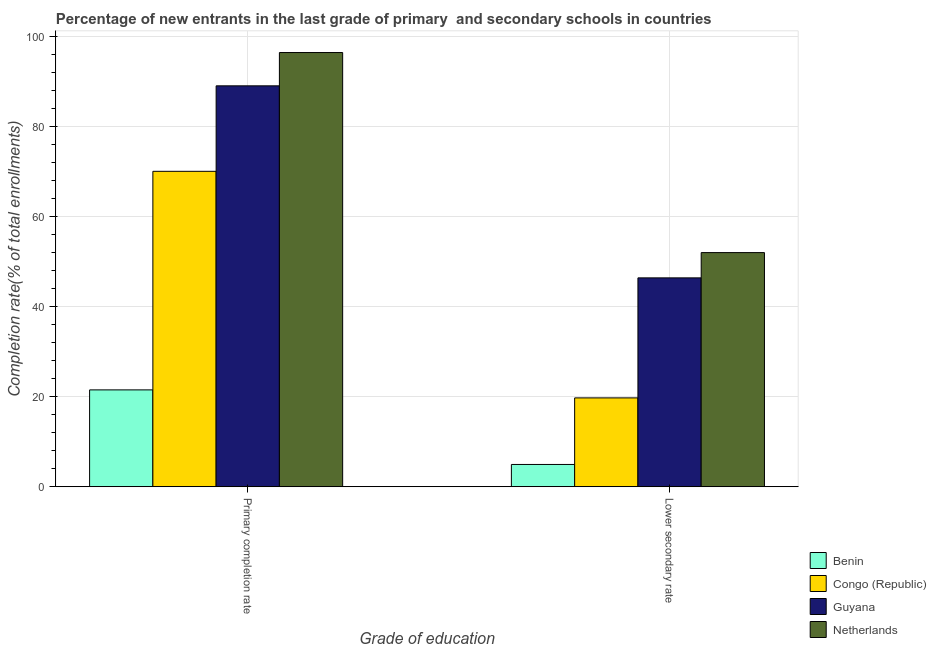How many groups of bars are there?
Give a very brief answer. 2. Are the number of bars on each tick of the X-axis equal?
Give a very brief answer. Yes. How many bars are there on the 1st tick from the right?
Provide a short and direct response. 4. What is the label of the 2nd group of bars from the left?
Offer a terse response. Lower secondary rate. What is the completion rate in secondary schools in Guyana?
Your answer should be very brief. 46.39. Across all countries, what is the maximum completion rate in primary schools?
Your response must be concise. 96.44. Across all countries, what is the minimum completion rate in primary schools?
Give a very brief answer. 21.51. In which country was the completion rate in secondary schools minimum?
Provide a short and direct response. Benin. What is the total completion rate in primary schools in the graph?
Make the answer very short. 277.05. What is the difference between the completion rate in primary schools in Guyana and that in Netherlands?
Your answer should be compact. -7.4. What is the difference between the completion rate in secondary schools in Netherlands and the completion rate in primary schools in Congo (Republic)?
Your response must be concise. -18.05. What is the average completion rate in primary schools per country?
Keep it short and to the point. 69.26. What is the difference between the completion rate in secondary schools and completion rate in primary schools in Netherlands?
Ensure brevity in your answer.  -44.44. In how many countries, is the completion rate in primary schools greater than 60 %?
Your response must be concise. 3. What is the ratio of the completion rate in secondary schools in Guyana to that in Congo (Republic)?
Your answer should be compact. 2.35. Is the completion rate in secondary schools in Benin less than that in Congo (Republic)?
Your response must be concise. Yes. What does the 4th bar from the left in Primary completion rate represents?
Ensure brevity in your answer.  Netherlands. What does the 3rd bar from the right in Primary completion rate represents?
Give a very brief answer. Congo (Republic). How many bars are there?
Offer a very short reply. 8. Are all the bars in the graph horizontal?
Make the answer very short. No. Are the values on the major ticks of Y-axis written in scientific E-notation?
Offer a terse response. No. Does the graph contain any zero values?
Your response must be concise. No. Where does the legend appear in the graph?
Provide a short and direct response. Bottom right. What is the title of the graph?
Give a very brief answer. Percentage of new entrants in the last grade of primary  and secondary schools in countries. What is the label or title of the X-axis?
Your answer should be compact. Grade of education. What is the label or title of the Y-axis?
Ensure brevity in your answer.  Completion rate(% of total enrollments). What is the Completion rate(% of total enrollments) in Benin in Primary completion rate?
Keep it short and to the point. 21.51. What is the Completion rate(% of total enrollments) in Congo (Republic) in Primary completion rate?
Your response must be concise. 70.06. What is the Completion rate(% of total enrollments) of Guyana in Primary completion rate?
Provide a short and direct response. 89.05. What is the Completion rate(% of total enrollments) in Netherlands in Primary completion rate?
Provide a succinct answer. 96.44. What is the Completion rate(% of total enrollments) in Benin in Lower secondary rate?
Offer a very short reply. 4.94. What is the Completion rate(% of total enrollments) in Congo (Republic) in Lower secondary rate?
Make the answer very short. 19.73. What is the Completion rate(% of total enrollments) in Guyana in Lower secondary rate?
Give a very brief answer. 46.39. What is the Completion rate(% of total enrollments) of Netherlands in Lower secondary rate?
Offer a very short reply. 52. Across all Grade of education, what is the maximum Completion rate(% of total enrollments) of Benin?
Your answer should be compact. 21.51. Across all Grade of education, what is the maximum Completion rate(% of total enrollments) in Congo (Republic)?
Your answer should be very brief. 70.06. Across all Grade of education, what is the maximum Completion rate(% of total enrollments) of Guyana?
Your answer should be very brief. 89.05. Across all Grade of education, what is the maximum Completion rate(% of total enrollments) in Netherlands?
Ensure brevity in your answer.  96.44. Across all Grade of education, what is the minimum Completion rate(% of total enrollments) in Benin?
Your response must be concise. 4.94. Across all Grade of education, what is the minimum Completion rate(% of total enrollments) of Congo (Republic)?
Your answer should be compact. 19.73. Across all Grade of education, what is the minimum Completion rate(% of total enrollments) of Guyana?
Your response must be concise. 46.39. Across all Grade of education, what is the minimum Completion rate(% of total enrollments) in Netherlands?
Your response must be concise. 52. What is the total Completion rate(% of total enrollments) in Benin in the graph?
Your response must be concise. 26.45. What is the total Completion rate(% of total enrollments) in Congo (Republic) in the graph?
Ensure brevity in your answer.  89.79. What is the total Completion rate(% of total enrollments) in Guyana in the graph?
Offer a very short reply. 135.44. What is the total Completion rate(% of total enrollments) of Netherlands in the graph?
Keep it short and to the point. 148.45. What is the difference between the Completion rate(% of total enrollments) of Benin in Primary completion rate and that in Lower secondary rate?
Make the answer very short. 16.57. What is the difference between the Completion rate(% of total enrollments) of Congo (Republic) in Primary completion rate and that in Lower secondary rate?
Provide a succinct answer. 50.33. What is the difference between the Completion rate(% of total enrollments) of Guyana in Primary completion rate and that in Lower secondary rate?
Your response must be concise. 42.66. What is the difference between the Completion rate(% of total enrollments) of Netherlands in Primary completion rate and that in Lower secondary rate?
Provide a short and direct response. 44.44. What is the difference between the Completion rate(% of total enrollments) of Benin in Primary completion rate and the Completion rate(% of total enrollments) of Congo (Republic) in Lower secondary rate?
Your answer should be compact. 1.78. What is the difference between the Completion rate(% of total enrollments) of Benin in Primary completion rate and the Completion rate(% of total enrollments) of Guyana in Lower secondary rate?
Offer a very short reply. -24.88. What is the difference between the Completion rate(% of total enrollments) in Benin in Primary completion rate and the Completion rate(% of total enrollments) in Netherlands in Lower secondary rate?
Provide a short and direct response. -30.49. What is the difference between the Completion rate(% of total enrollments) in Congo (Republic) in Primary completion rate and the Completion rate(% of total enrollments) in Guyana in Lower secondary rate?
Give a very brief answer. 23.67. What is the difference between the Completion rate(% of total enrollments) of Congo (Republic) in Primary completion rate and the Completion rate(% of total enrollments) of Netherlands in Lower secondary rate?
Offer a terse response. 18.05. What is the difference between the Completion rate(% of total enrollments) in Guyana in Primary completion rate and the Completion rate(% of total enrollments) in Netherlands in Lower secondary rate?
Keep it short and to the point. 37.04. What is the average Completion rate(% of total enrollments) in Benin per Grade of education?
Offer a very short reply. 13.23. What is the average Completion rate(% of total enrollments) in Congo (Republic) per Grade of education?
Ensure brevity in your answer.  44.89. What is the average Completion rate(% of total enrollments) in Guyana per Grade of education?
Give a very brief answer. 67.72. What is the average Completion rate(% of total enrollments) in Netherlands per Grade of education?
Provide a succinct answer. 74.22. What is the difference between the Completion rate(% of total enrollments) of Benin and Completion rate(% of total enrollments) of Congo (Republic) in Primary completion rate?
Offer a terse response. -48.55. What is the difference between the Completion rate(% of total enrollments) of Benin and Completion rate(% of total enrollments) of Guyana in Primary completion rate?
Make the answer very short. -67.53. What is the difference between the Completion rate(% of total enrollments) in Benin and Completion rate(% of total enrollments) in Netherlands in Primary completion rate?
Offer a very short reply. -74.93. What is the difference between the Completion rate(% of total enrollments) in Congo (Republic) and Completion rate(% of total enrollments) in Guyana in Primary completion rate?
Your answer should be compact. -18.99. What is the difference between the Completion rate(% of total enrollments) in Congo (Republic) and Completion rate(% of total enrollments) in Netherlands in Primary completion rate?
Offer a very short reply. -26.38. What is the difference between the Completion rate(% of total enrollments) in Guyana and Completion rate(% of total enrollments) in Netherlands in Primary completion rate?
Provide a short and direct response. -7.4. What is the difference between the Completion rate(% of total enrollments) of Benin and Completion rate(% of total enrollments) of Congo (Republic) in Lower secondary rate?
Keep it short and to the point. -14.79. What is the difference between the Completion rate(% of total enrollments) of Benin and Completion rate(% of total enrollments) of Guyana in Lower secondary rate?
Provide a short and direct response. -41.45. What is the difference between the Completion rate(% of total enrollments) in Benin and Completion rate(% of total enrollments) in Netherlands in Lower secondary rate?
Give a very brief answer. -47.06. What is the difference between the Completion rate(% of total enrollments) in Congo (Republic) and Completion rate(% of total enrollments) in Guyana in Lower secondary rate?
Make the answer very short. -26.66. What is the difference between the Completion rate(% of total enrollments) of Congo (Republic) and Completion rate(% of total enrollments) of Netherlands in Lower secondary rate?
Provide a short and direct response. -32.27. What is the difference between the Completion rate(% of total enrollments) in Guyana and Completion rate(% of total enrollments) in Netherlands in Lower secondary rate?
Make the answer very short. -5.61. What is the ratio of the Completion rate(% of total enrollments) in Benin in Primary completion rate to that in Lower secondary rate?
Ensure brevity in your answer.  4.35. What is the ratio of the Completion rate(% of total enrollments) in Congo (Republic) in Primary completion rate to that in Lower secondary rate?
Your answer should be compact. 3.55. What is the ratio of the Completion rate(% of total enrollments) of Guyana in Primary completion rate to that in Lower secondary rate?
Offer a very short reply. 1.92. What is the ratio of the Completion rate(% of total enrollments) in Netherlands in Primary completion rate to that in Lower secondary rate?
Your response must be concise. 1.85. What is the difference between the highest and the second highest Completion rate(% of total enrollments) of Benin?
Give a very brief answer. 16.57. What is the difference between the highest and the second highest Completion rate(% of total enrollments) of Congo (Republic)?
Provide a succinct answer. 50.33. What is the difference between the highest and the second highest Completion rate(% of total enrollments) of Guyana?
Offer a very short reply. 42.66. What is the difference between the highest and the second highest Completion rate(% of total enrollments) in Netherlands?
Ensure brevity in your answer.  44.44. What is the difference between the highest and the lowest Completion rate(% of total enrollments) in Benin?
Offer a terse response. 16.57. What is the difference between the highest and the lowest Completion rate(% of total enrollments) in Congo (Republic)?
Your answer should be compact. 50.33. What is the difference between the highest and the lowest Completion rate(% of total enrollments) of Guyana?
Make the answer very short. 42.66. What is the difference between the highest and the lowest Completion rate(% of total enrollments) of Netherlands?
Offer a terse response. 44.44. 